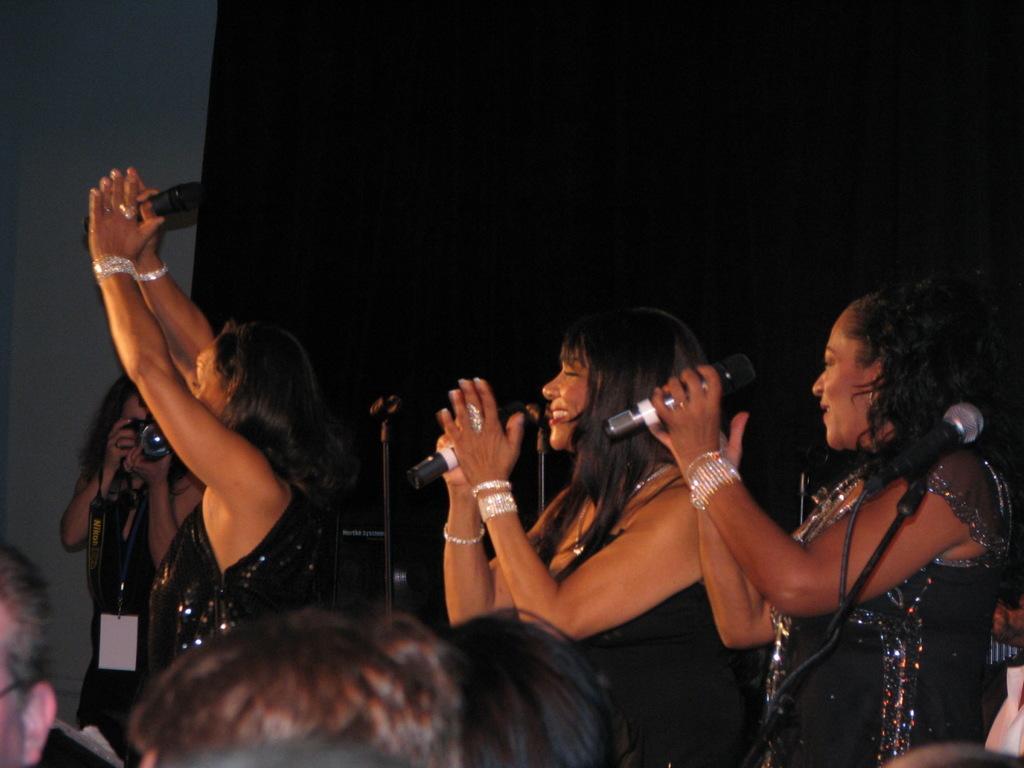Could you give a brief overview of what you see in this image? This picture is clicked inside. In the foreground we can see the persons. In the center we can see the three persons holding microphones and standing on the ground. In the background there is a wall and a curtain and we can see a person holding a camera and seems to be taking pictures. 